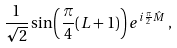Convert formula to latex. <formula><loc_0><loc_0><loc_500><loc_500>\frac { 1 } { \sqrt { 2 } } \sin \left ( \frac { \pi } { 4 } ( L + 1 ) \right ) e ^ { i \frac { \pi } { 2 } \hat { M } } \, ,</formula> 